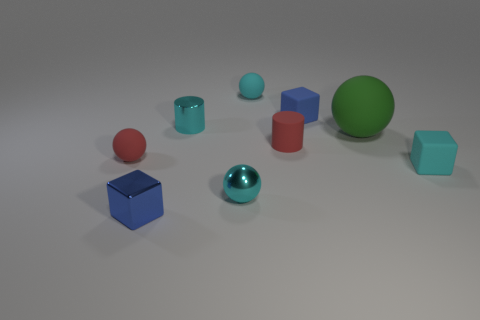Subtract 1 balls. How many balls are left? 3 Add 1 small cyan metallic cylinders. How many objects exist? 10 Subtract all cylinders. How many objects are left? 7 Add 7 small cyan cubes. How many small cyan cubes exist? 8 Subtract 1 cyan spheres. How many objects are left? 8 Subtract all large matte objects. Subtract all cyan metal things. How many objects are left? 6 Add 7 tiny blue blocks. How many tiny blue blocks are left? 9 